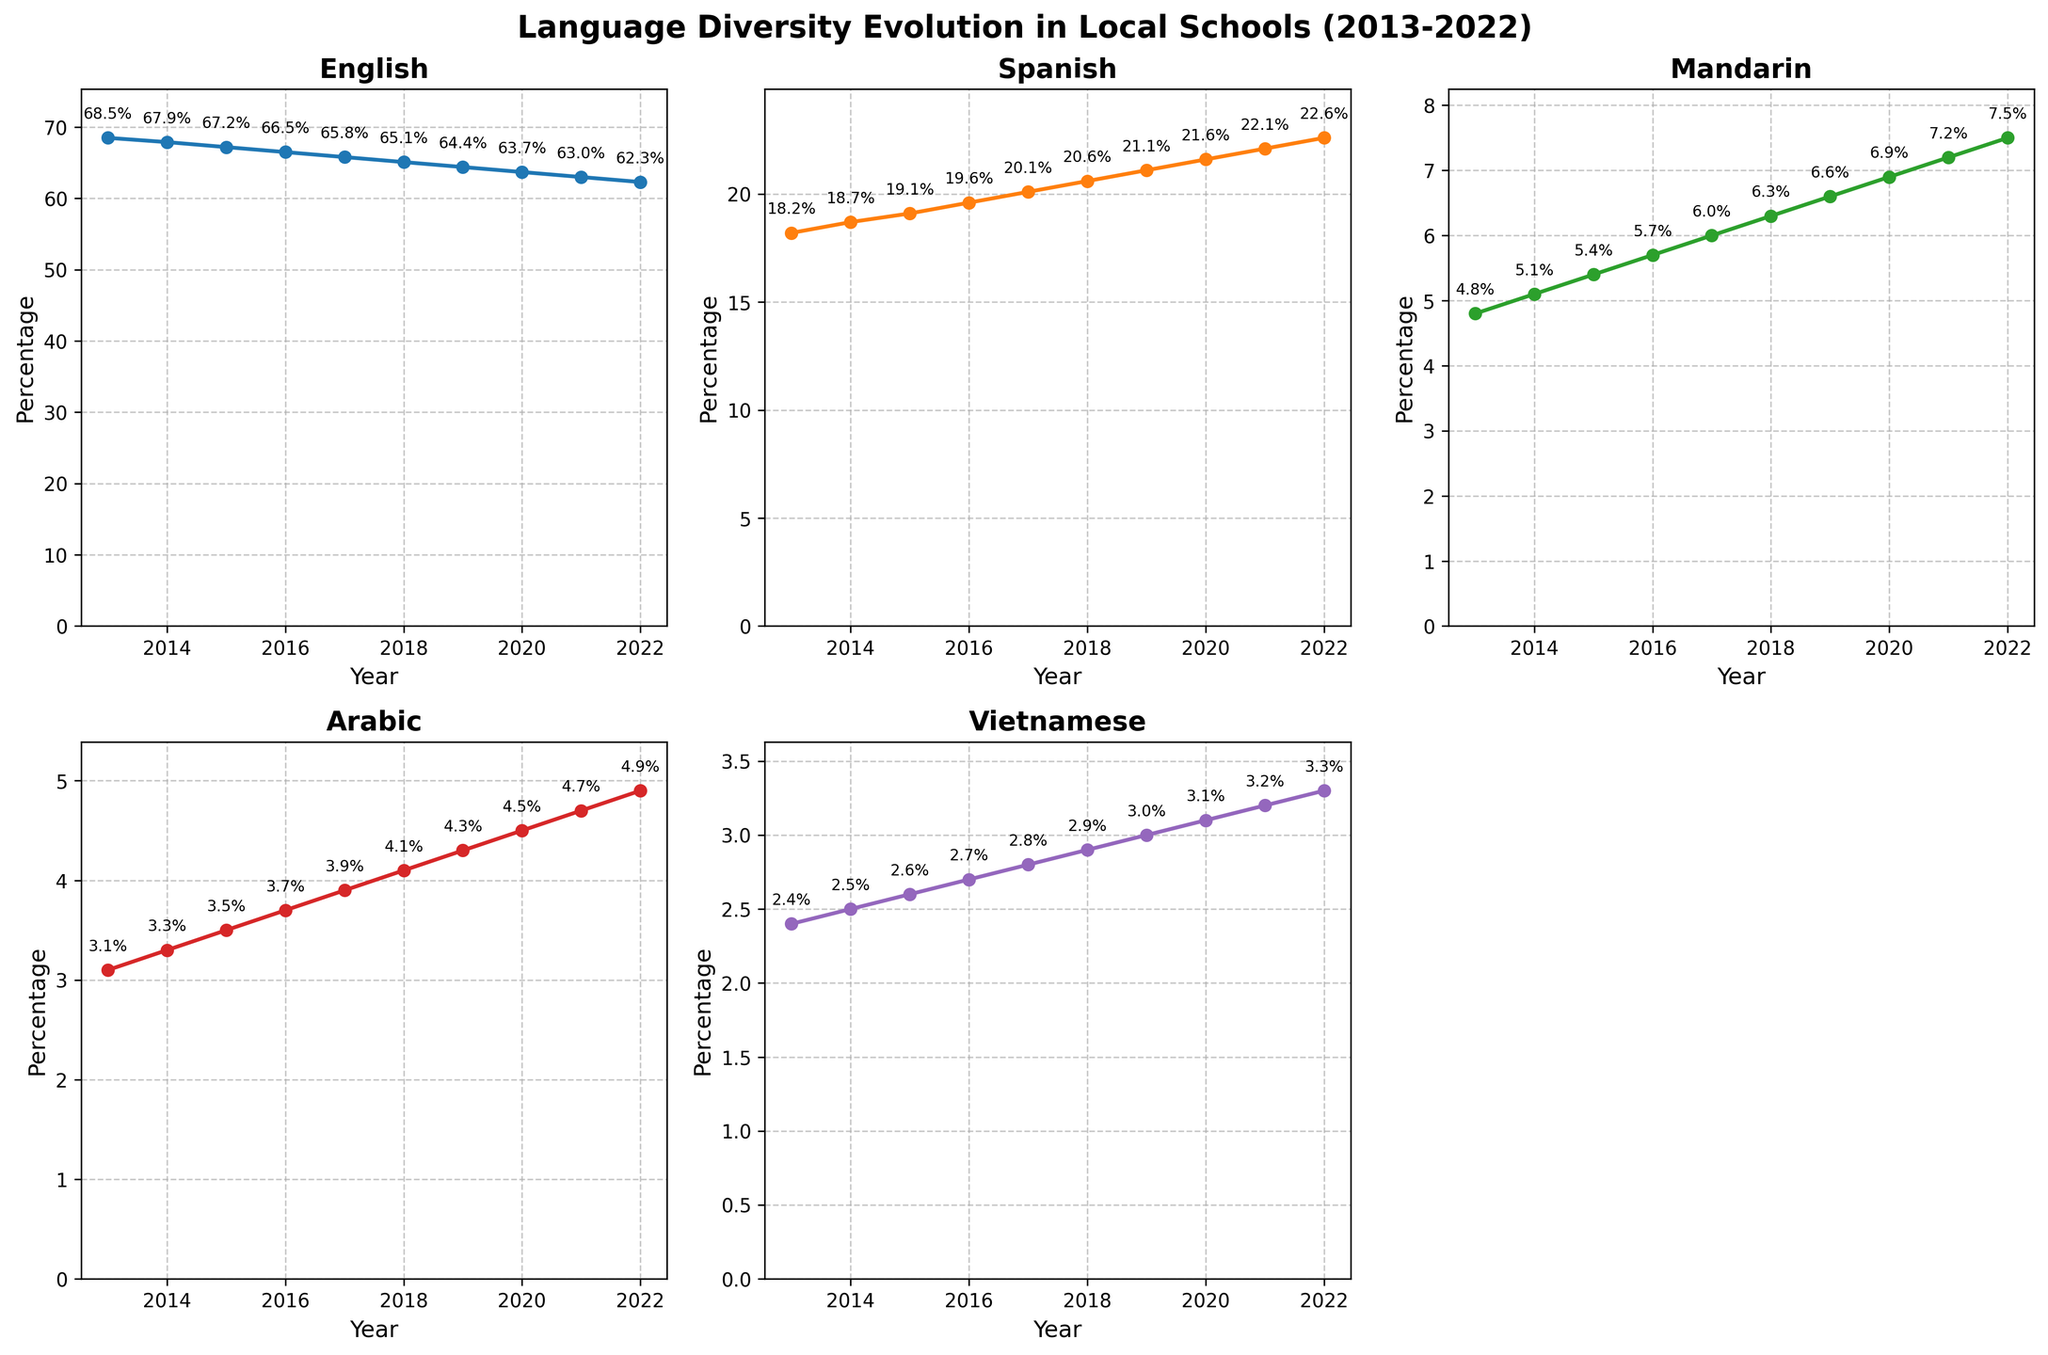What's the percentage difference between Spanish and Mandarin in 2022? The percentage for Spanish in 2022 is 22.6%, and for Mandarin, it is 7.5%. The difference is 22.6% - 7.5% = 15.1%.
Answer: 15.1% Which language experienced the highest increase in percentage from 2013 to 2022? English decreased, so we’ll look at the other four. Spanish rose from 18.2% to 22.6%, an increase of 4.4%. Mandarin rose from 4.8% to 7.5%, an increase of 2.7%. Arabic rose from 3.1% to 4.9%, an increase of 1.8%. Vietnamese rose from 2.4% to 3.3%, an increase of 0.9%. Spanish experienced the highest increase at 4.4%.
Answer: Spanish Between which years did Arabic see the most significant increase? From year to year, Arabic increased as follows: 2013-2014: 0.2%, 2014-2015: 0.2%, 2015-2016: 0.2%, 2016-2017: 0.2%, 2017-2018: 0.2%, 2018-2019: 0.2%, 2019-2020: 0.2%, 2020-2021: 0.2%, 2021-2022: 0.2%. Hence, it saw a consistent increase of 0.2% each year, no single year stands out more than the others.
Answer: All years saw a 0.2% increase In which year did Vietnamese cross the 3% mark, and what was the percentage that year? Vietnamese was at 3% in 2019 and increased to 3.1% in 2020. Therefore, it crossed the 3% mark in 2020.
Answer: 2020, 3.1% Compare the trend of English and Spanish over the decade. How do they relate to each other? English experienced a decline, starting at 68.5% in 2013 and ending at 62.3% in 2022. In contrast, Spanish showed an increasing trend, starting at 18.2% in 2013 and ending at 22.6% in 2022. While English decreased, Spanish increased.
Answer: English decreased, Spanish increased What's the sum of the percentages of English and Spanish in 2017? The percentage for English in 2017 is 65.8%, and for Spanish is 20.1%. The sum is 65.8% + 20.1% = 85.9%.
Answer: 85.9% What visual trend can be observed from the plots for Mandarin and Arabic? Both Mandarin and Arabic show an upward trend, gradually increasing their percentages each year from 2013 to 2022.
Answer: Both trending upward Which language had the smallest percentage change over the decade? Vietnamese rose from 2.4% in 2013 to 3.3% in 2022, an increase of 0.9%, which is the smallest change compared to other languages.
Answer: Vietnamese How did the percentage of English change from 2013 to 2022? English decreased from 68.5% in 2013 to 62.3% in 2022. The change is 68.5% - 62.3% = -6.2%.
Answer: Decreased by 6.2% 